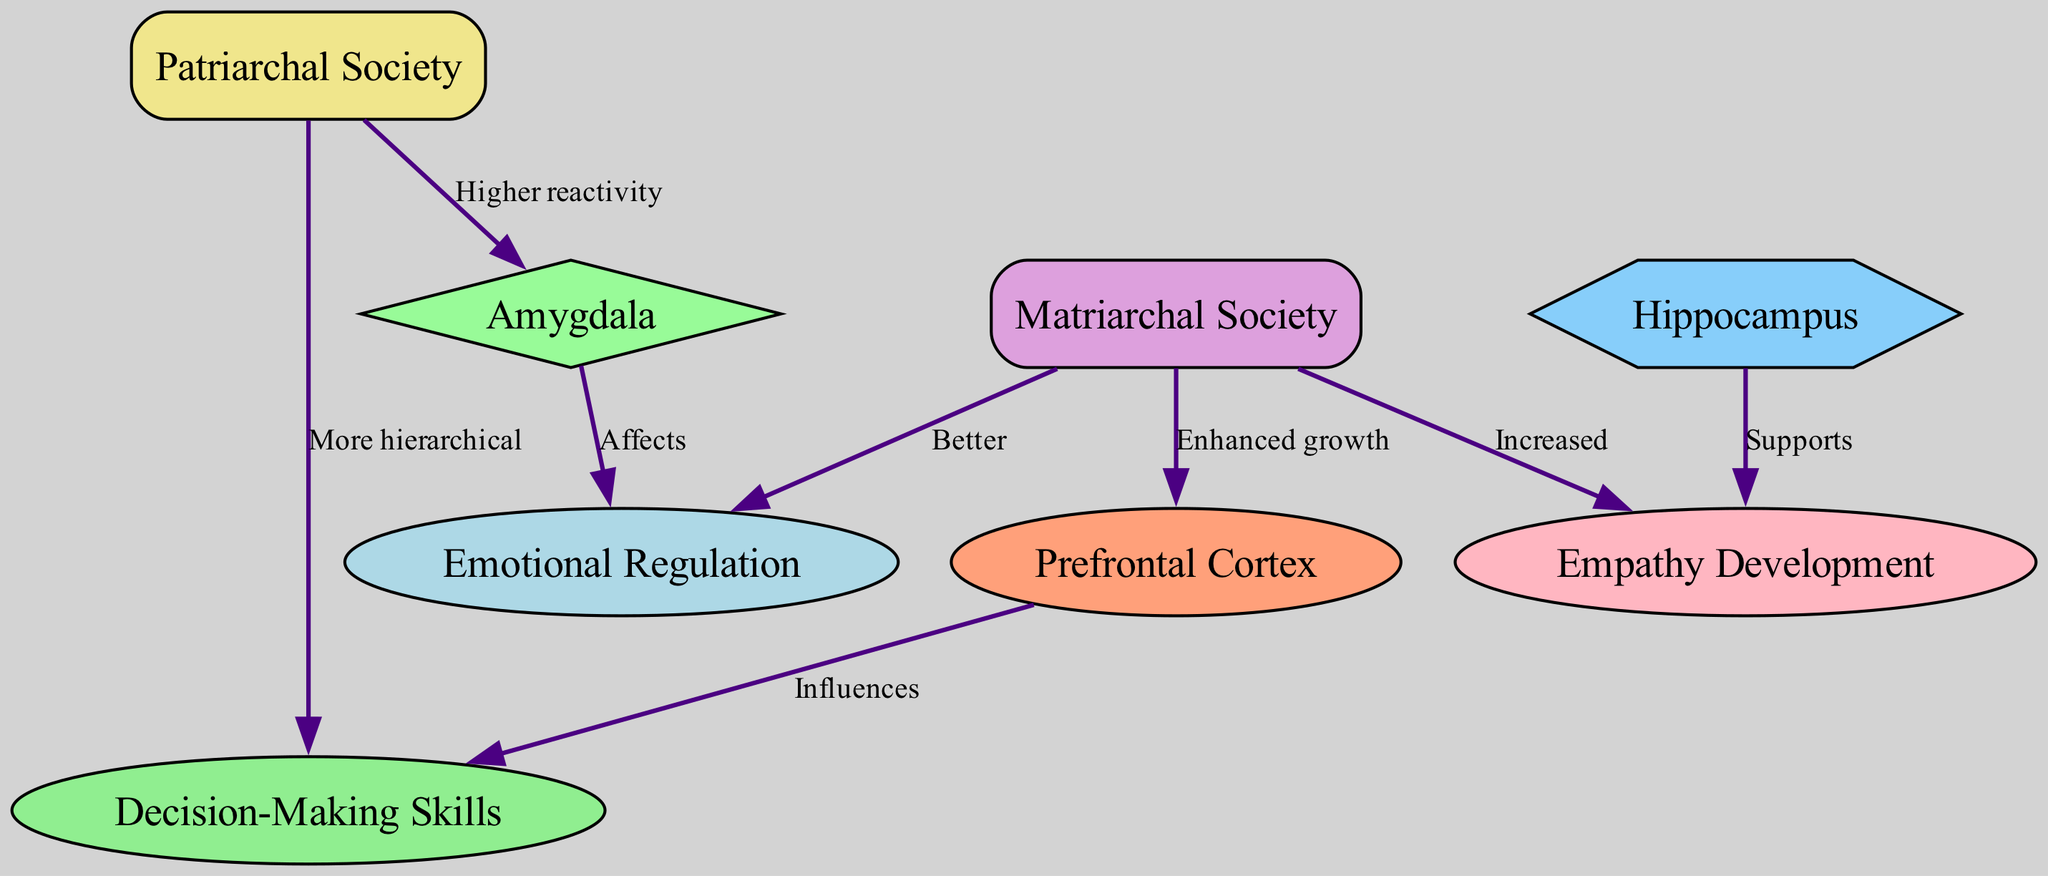What is enhanced growth in the prefrontal cortex associated with? The diagram shows that enhanced growth in the prefrontal cortex is linked to children raised in a matriarchal society. This relationship is represented by an edge labeled "Enhanced growth" that connects the node "Matriarchal Society" to "Prefrontal Cortex."
Answer: Matriarchal Society How many nodes are present in the diagram? By counting the nodes in the data, we find there are eight nodes listed: Prefrontal Cortex, Amygdala, Hippocampus, Matriarchal Society, Patriarchal Society, Empathy Development, Emotional Regulation, and Decision-Making Skills. Hence, the total count is eight.
Answer: Eight What is the relationship between the amygdala and emotional regulation in children raised in patriarchal societies? According to the diagram, the edge labeled "Affects" indicates that the amygdala has a direct effect on emotional regulation in children raised in patriarchal societies. This shows that behaviors or traits linked to the amygdala influence emotional regulation.
Answer: Affects Which society is associated with increased empathy development? The diagram shows an edge leading from "Matriarchal Society" to "Empathy Development," labeled "Increased." This indicates that children raised in matriarchal societies show a greater level of empathy development compared to other societies.
Answer: Matriarchal Society What type of society leads to more hierarchical decision-making skills? The edge connecting "Patriarchal Society" to "Decision-Making Skills," labeled "More hierarchical," suggests that children raised in patriarchal societies are associated with more hierarchical decision-making skills. This implies a tendency for conformity to established social structures in decision-making.
Answer: Patriarchal Society 